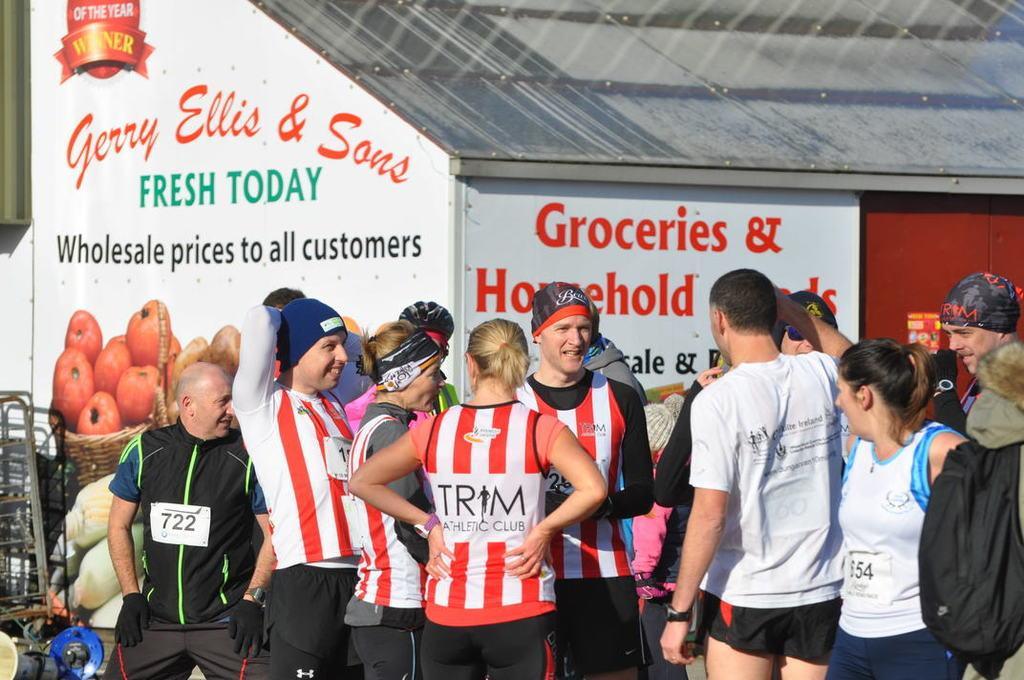Describe this image in one or two sentences. At the bottom of this image, there are persons in different color dresses. Some of them are smiling. In the background, there are posters pasted on the walls of a building which is having a roof and there are other objects. 